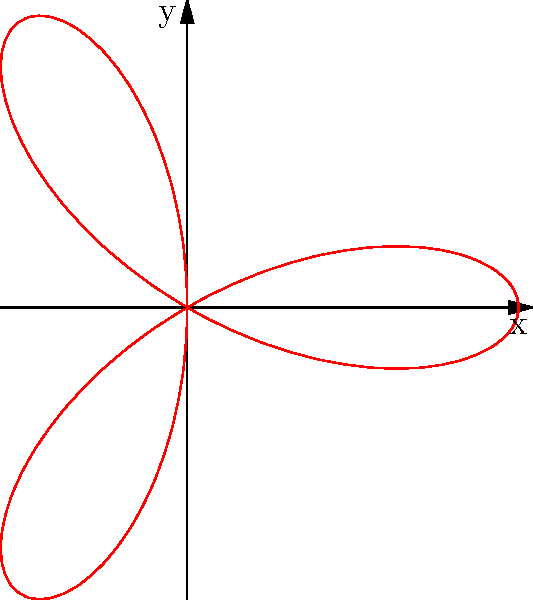Given the polar rose $r = \cos(3\theta)$, calculate its area using integration. Round your answer to two decimal places. To find the area of a polar rose, we can use the formula:

$$A = \frac{1}{2} \int_0^{2\pi} r^2 d\theta$$

For this polar rose, $r = \cos(3\theta)$. Let's follow these steps:

1) Substitute $r = \cos(3\theta)$ into the formula:
   $$A = \frac{1}{2} \int_0^{2\pi} \cos^2(3\theta) d\theta$$

2) Use the trigonometric identity $\cos^2(x) = \frac{1 + \cos(2x)}{2}$:
   $$A = \frac{1}{2} \int_0^{2\pi} \frac{1 + \cos(6\theta)}{2} d\theta$$

3) Simplify:
   $$A = \frac{1}{4} \int_0^{2\pi} [1 + \cos(6\theta)] d\theta$$

4) Integrate:
   $$A = \frac{1}{4} [\theta + \frac{1}{6}\sin(6\theta)]_0^{2\pi}$$

5) Evaluate the definite integral:
   $$A = \frac{1}{4} [(2\pi + 0) - (0 + 0)] = \frac{\pi}{2}$$

6) Round to two decimal places:
   $$A \approx 1.57$$
Answer: 1.57 